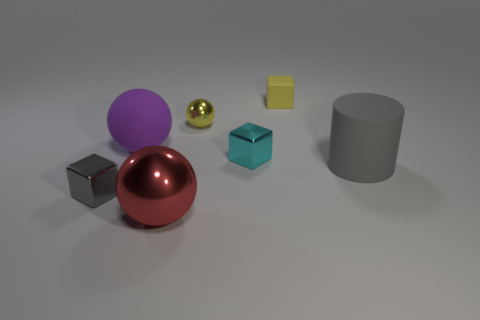Is the gray rubber object the same shape as the tiny yellow metallic thing?
Provide a succinct answer. No. What shape is the tiny thing that is the same color as the small metallic ball?
Provide a succinct answer. Cube. What number of matte things are either tiny yellow objects or cyan objects?
Give a very brief answer. 1. What color is the metallic sphere that is behind the gray thing that is to the right of the small metallic cube right of the tiny gray metal object?
Your answer should be compact. Yellow. There is a small metal object that is the same shape as the big purple matte thing; what is its color?
Give a very brief answer. Yellow. Is there any other thing that has the same color as the rubber sphere?
Your answer should be very brief. No. How many other objects are the same material as the red ball?
Provide a succinct answer. 3. What is the size of the yellow metallic ball?
Your answer should be compact. Small. Is there a big purple thing of the same shape as the yellow rubber thing?
Your answer should be compact. No. How many things are large red metal objects or big matte objects in front of the cyan metallic thing?
Make the answer very short. 2. 